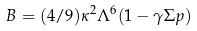Convert formula to latex. <formula><loc_0><loc_0><loc_500><loc_500>B = ( 4 / 9 ) \kappa ^ { 2 } \Lambda ^ { 6 } ( 1 - \gamma \Sigma p )</formula> 